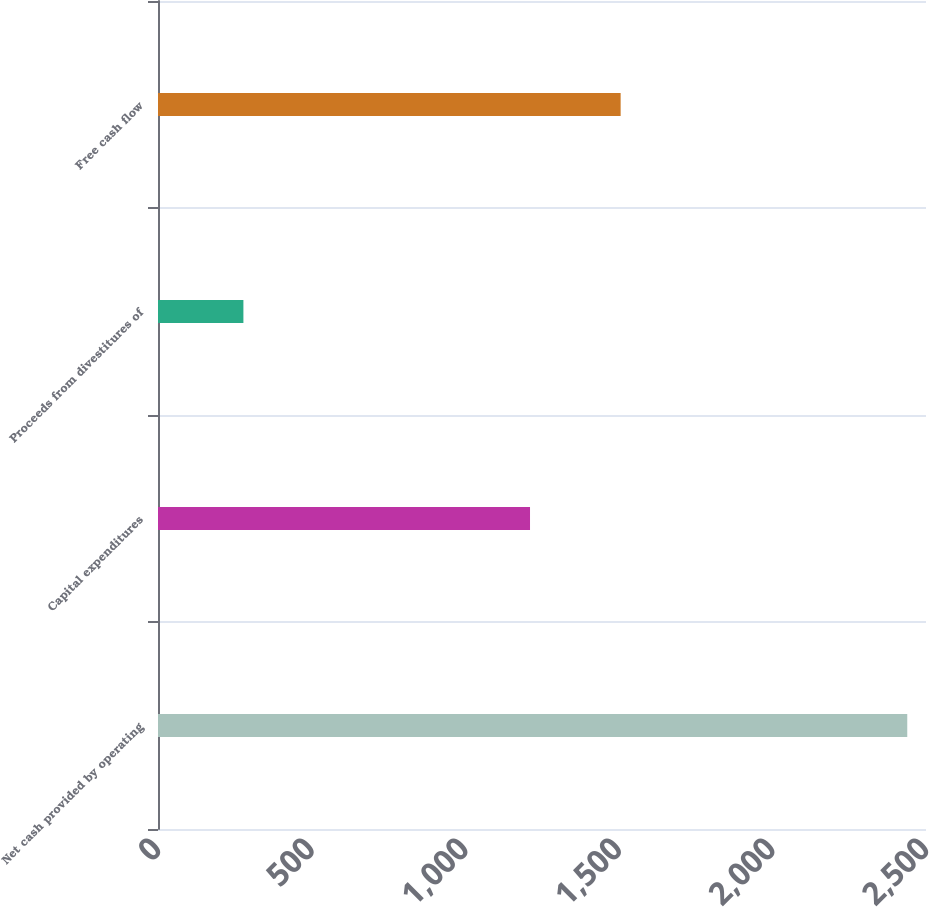<chart> <loc_0><loc_0><loc_500><loc_500><bar_chart><fcel>Net cash provided by operating<fcel>Capital expenditures<fcel>Proceeds from divestitures of<fcel>Free cash flow<nl><fcel>2439<fcel>1211<fcel>278<fcel>1506<nl></chart> 